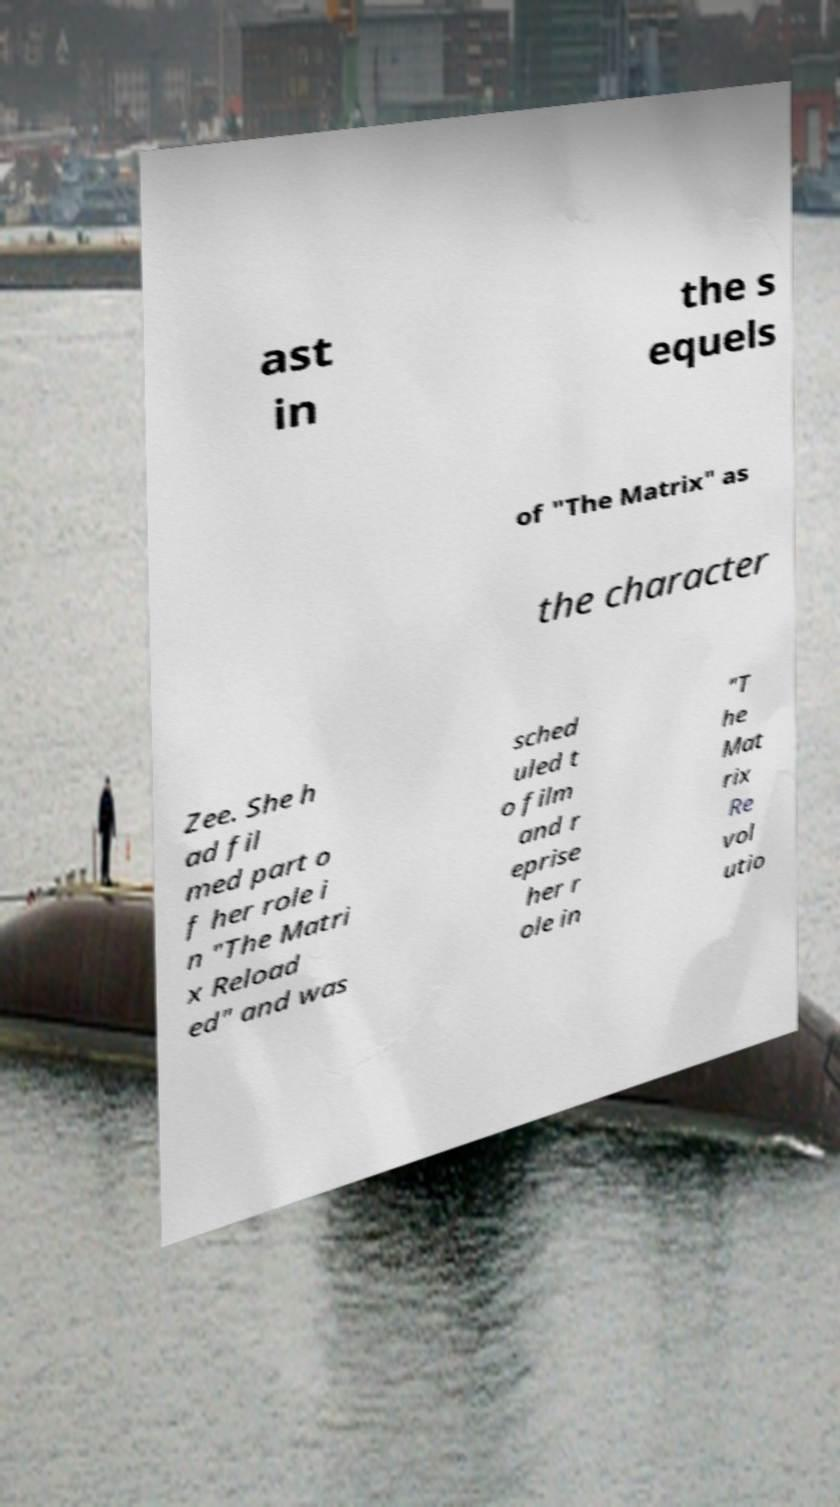Could you assist in decoding the text presented in this image and type it out clearly? ast in the s equels of "The Matrix" as the character Zee. She h ad fil med part o f her role i n "The Matri x Reload ed" and was sched uled t o film and r eprise her r ole in "T he Mat rix Re vol utio 